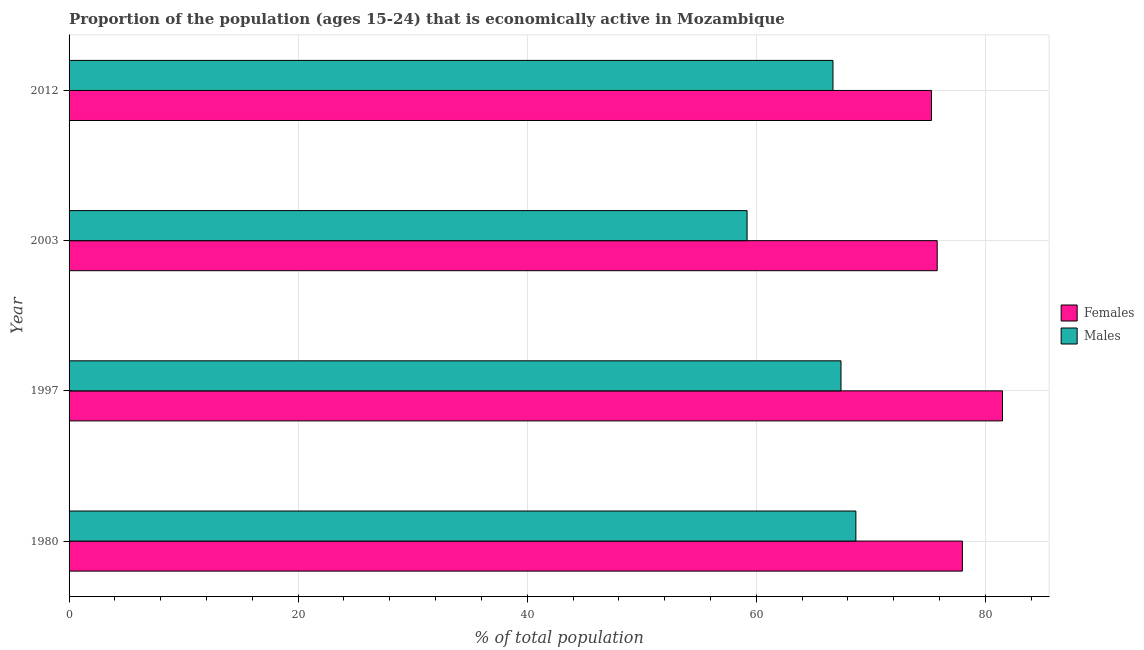How many different coloured bars are there?
Keep it short and to the point. 2. Are the number of bars per tick equal to the number of legend labels?
Make the answer very short. Yes. What is the percentage of economically active female population in 1997?
Give a very brief answer. 81.5. Across all years, what is the maximum percentage of economically active male population?
Your answer should be very brief. 68.7. Across all years, what is the minimum percentage of economically active male population?
Provide a succinct answer. 59.2. What is the total percentage of economically active male population in the graph?
Offer a very short reply. 262. What is the difference between the percentage of economically active male population in 1980 and the percentage of economically active female population in 2012?
Keep it short and to the point. -6.6. What is the average percentage of economically active female population per year?
Provide a short and direct response. 77.65. What is the ratio of the percentage of economically active female population in 1980 to that in 2012?
Offer a very short reply. 1.04. Is the percentage of economically active male population in 1997 less than that in 2012?
Give a very brief answer. No. What is the difference between the highest and the second highest percentage of economically active male population?
Give a very brief answer. 1.3. In how many years, is the percentage of economically active female population greater than the average percentage of economically active female population taken over all years?
Make the answer very short. 2. Is the sum of the percentage of economically active female population in 1997 and 2003 greater than the maximum percentage of economically active male population across all years?
Ensure brevity in your answer.  Yes. What does the 2nd bar from the top in 1997 represents?
Offer a terse response. Females. What does the 1st bar from the bottom in 2003 represents?
Ensure brevity in your answer.  Females. How many years are there in the graph?
Offer a very short reply. 4. What is the difference between two consecutive major ticks on the X-axis?
Offer a terse response. 20. How are the legend labels stacked?
Offer a terse response. Vertical. What is the title of the graph?
Provide a succinct answer. Proportion of the population (ages 15-24) that is economically active in Mozambique. What is the label or title of the X-axis?
Keep it short and to the point. % of total population. What is the label or title of the Y-axis?
Your response must be concise. Year. What is the % of total population of Females in 1980?
Your answer should be compact. 78. What is the % of total population in Males in 1980?
Your response must be concise. 68.7. What is the % of total population in Females in 1997?
Offer a terse response. 81.5. What is the % of total population in Males in 1997?
Ensure brevity in your answer.  67.4. What is the % of total population in Females in 2003?
Make the answer very short. 75.8. What is the % of total population of Males in 2003?
Ensure brevity in your answer.  59.2. What is the % of total population in Females in 2012?
Offer a very short reply. 75.3. What is the % of total population of Males in 2012?
Offer a very short reply. 66.7. Across all years, what is the maximum % of total population in Females?
Offer a terse response. 81.5. Across all years, what is the maximum % of total population of Males?
Provide a succinct answer. 68.7. Across all years, what is the minimum % of total population of Females?
Keep it short and to the point. 75.3. Across all years, what is the minimum % of total population of Males?
Your answer should be compact. 59.2. What is the total % of total population of Females in the graph?
Offer a terse response. 310.6. What is the total % of total population of Males in the graph?
Make the answer very short. 262. What is the difference between the % of total population of Females in 1980 and that in 2003?
Your answer should be compact. 2.2. What is the difference between the % of total population in Males in 1980 and that in 2003?
Provide a succinct answer. 9.5. What is the difference between the % of total population in Males in 1980 and that in 2012?
Your response must be concise. 2. What is the difference between the % of total population of Females in 1997 and that in 2003?
Your response must be concise. 5.7. What is the difference between the % of total population of Males in 1997 and that in 2003?
Provide a succinct answer. 8.2. What is the difference between the % of total population in Females in 1997 and that in 2012?
Your answer should be very brief. 6.2. What is the difference between the % of total population in Females in 2003 and that in 2012?
Offer a terse response. 0.5. What is the difference between the % of total population of Males in 2003 and that in 2012?
Ensure brevity in your answer.  -7.5. What is the difference between the % of total population of Females in 1980 and the % of total population of Males in 1997?
Make the answer very short. 10.6. What is the difference between the % of total population in Females in 1980 and the % of total population in Males in 2003?
Your answer should be compact. 18.8. What is the difference between the % of total population in Females in 1980 and the % of total population in Males in 2012?
Your answer should be very brief. 11.3. What is the difference between the % of total population in Females in 1997 and the % of total population in Males in 2003?
Give a very brief answer. 22.3. What is the difference between the % of total population in Females in 1997 and the % of total population in Males in 2012?
Your answer should be compact. 14.8. What is the difference between the % of total population in Females in 2003 and the % of total population in Males in 2012?
Make the answer very short. 9.1. What is the average % of total population of Females per year?
Your answer should be very brief. 77.65. What is the average % of total population of Males per year?
Your answer should be compact. 65.5. In the year 1980, what is the difference between the % of total population in Females and % of total population in Males?
Offer a terse response. 9.3. What is the ratio of the % of total population in Females in 1980 to that in 1997?
Your response must be concise. 0.96. What is the ratio of the % of total population of Males in 1980 to that in 1997?
Offer a terse response. 1.02. What is the ratio of the % of total population in Males in 1980 to that in 2003?
Give a very brief answer. 1.16. What is the ratio of the % of total population of Females in 1980 to that in 2012?
Make the answer very short. 1.04. What is the ratio of the % of total population in Males in 1980 to that in 2012?
Offer a very short reply. 1.03. What is the ratio of the % of total population in Females in 1997 to that in 2003?
Keep it short and to the point. 1.08. What is the ratio of the % of total population in Males in 1997 to that in 2003?
Ensure brevity in your answer.  1.14. What is the ratio of the % of total population in Females in 1997 to that in 2012?
Your answer should be compact. 1.08. What is the ratio of the % of total population of Males in 1997 to that in 2012?
Offer a terse response. 1.01. What is the ratio of the % of total population of Females in 2003 to that in 2012?
Your response must be concise. 1.01. What is the ratio of the % of total population of Males in 2003 to that in 2012?
Offer a very short reply. 0.89. What is the difference between the highest and the second highest % of total population of Females?
Provide a short and direct response. 3.5. What is the difference between the highest and the lowest % of total population in Males?
Provide a short and direct response. 9.5. 